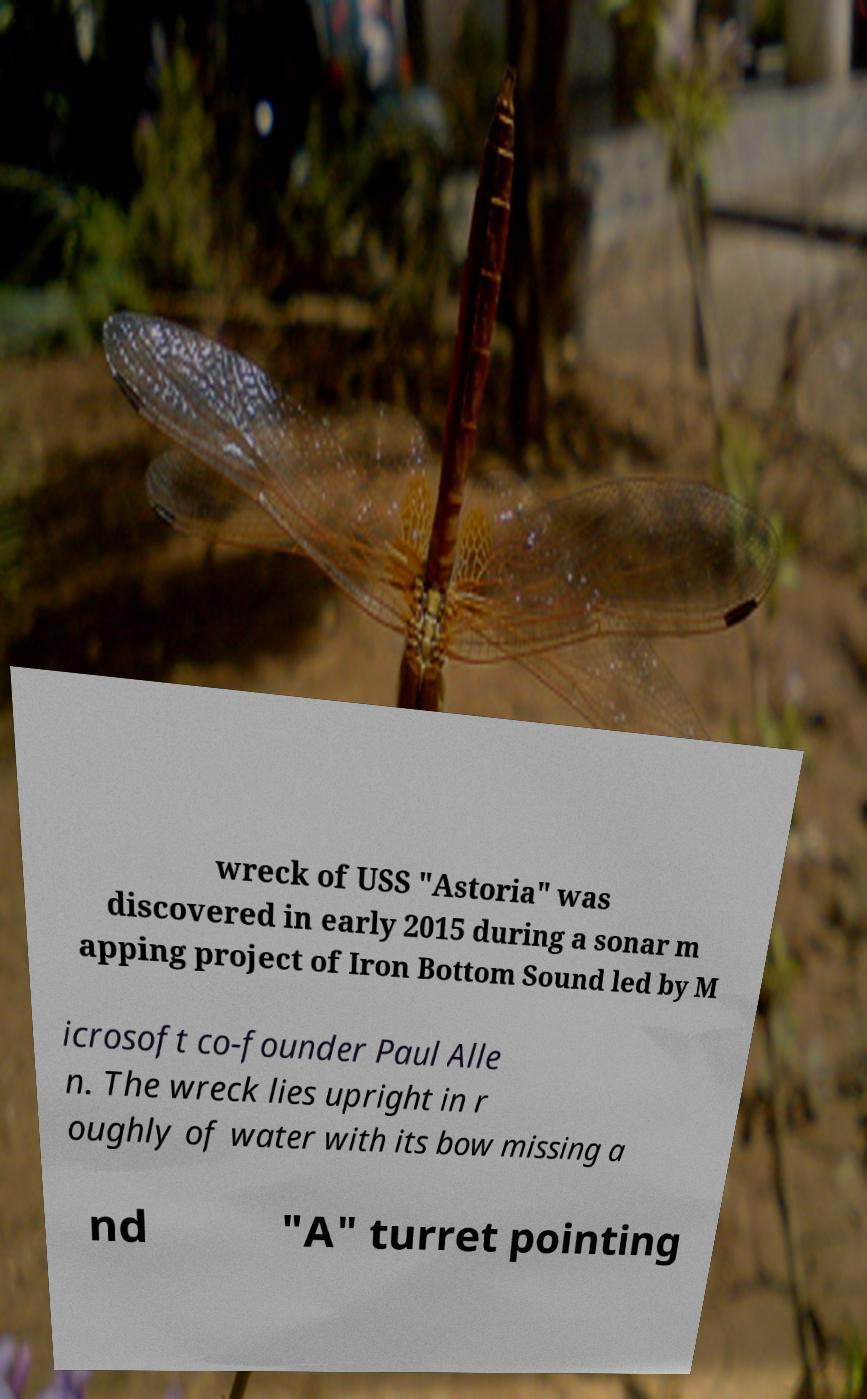There's text embedded in this image that I need extracted. Can you transcribe it verbatim? wreck of USS "Astoria" was discovered in early 2015 during a sonar m apping project of Iron Bottom Sound led by M icrosoft co-founder Paul Alle n. The wreck lies upright in r oughly of water with its bow missing a nd "A" turret pointing 